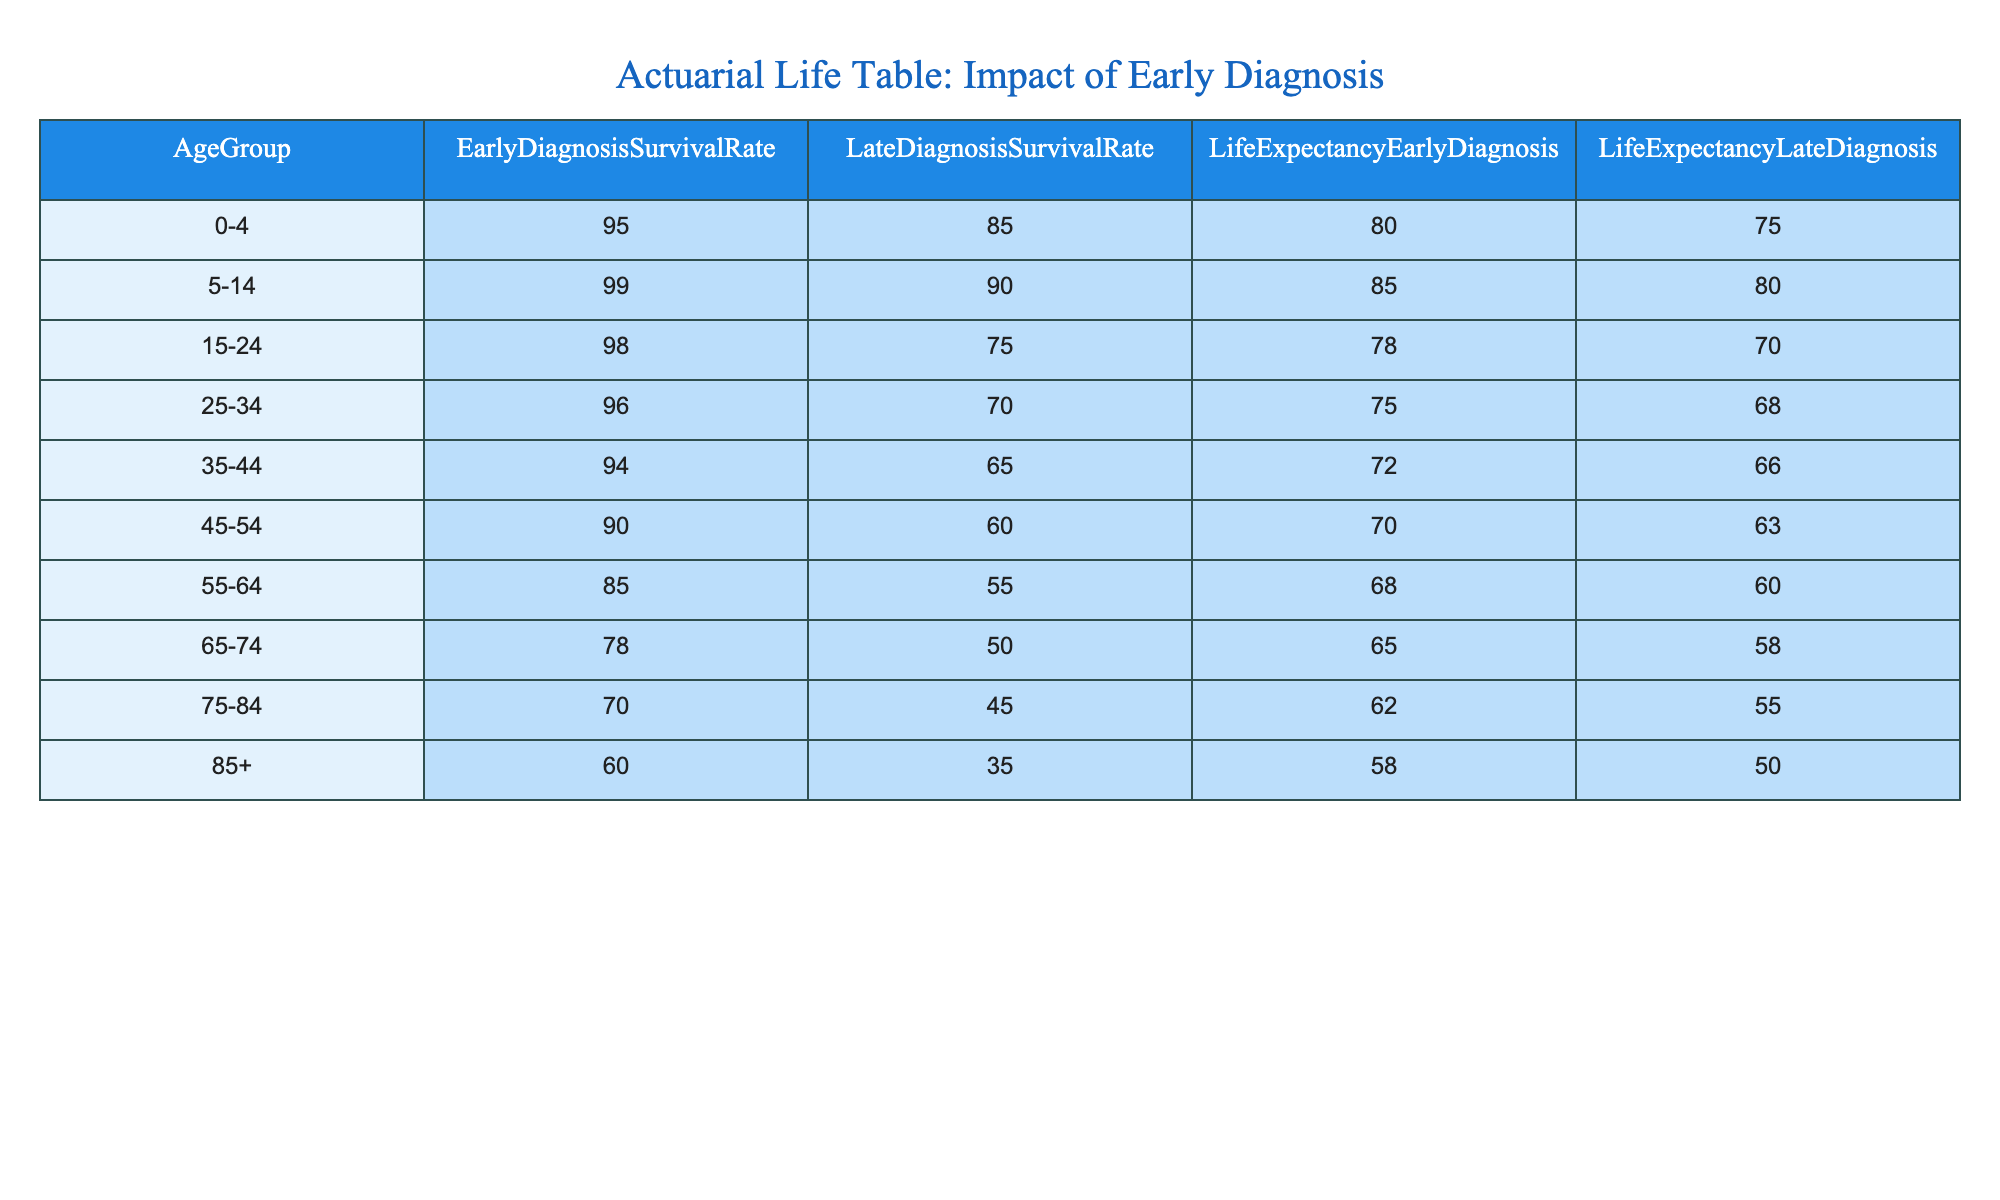What is the Early Diagnosis Survival Rate for the age group 25-34? The table specifies that for the age group 25-34, the Early Diagnosis Survival Rate is listed as 96.
Answer: 96 What is the Life Expectancy for Late Diagnosis in the 75-84 age group? According to the table, the Life Expectancy for Late Diagnosis in the 75-84 age group is noted as 55.
Answer: 55 For which age group is the difference between Early Diagnosis Survival Rate and Late Diagnosis Survival Rate the largest? The largest difference in Survival Rates can be found for the age group 0-4, where Early Diagnosis is 95 and Late Diagnosis is 85, making the difference 10.
Answer: 0-4 What is the average Life Expectancy for Early Diagnosis across all age groups? To find the average Life Expectancy for Early Diagnosis, we sum the values (80 + 85 + 78 + 75 + 72 + 70 + 68 + 65 + 62 + 58) = 778, then divide by the number of age groups (10), resulting in an average of 77.8.
Answer: 77.8 Is the Late Diagnosis Survival Rate lower for younger age groups compared to older age groups? Comparing the Late Diagnosis Survival Rates in younger age groups (0-4 to 25-34) which range from 85 to 70, with older age groups (55+), we note that the rates are 55, 50, 45, and 35. It is clear that the rates for older groups are lower.
Answer: Yes What is the Life Expectancy for the age group 85+ under Early Diagnosis compared to the 0-4 age group? The Life Expectancy for Early Diagnosis in the age group 85+ is 58, while for the 0-4 age group it is 80. The 85+ age group has a lower Life Expectancy by a value of 22.
Answer: 58 vs 80 Which age group experiences the smallest difference between Early and Late Diagnosis Life Expectancy? The age group 85+ shows the smallest difference, with Life Expectancy of 58 for Early Diagnosis and 50 for Late Diagnosis, a difference of only 8.
Answer: 85+ What is the total difference in Survival Rates when comparing the 15-24 age group with the 55-64 age group? The Early Diagnosis Survival Rate for 15-24 is 98, and for 55-64 it is 85. The Late Diagnosis Survival Rates are 75 and 55 respectively. This gives a total difference of (98 - 85) + (75 - 55) = 13 + 20 = 33.
Answer: 33 